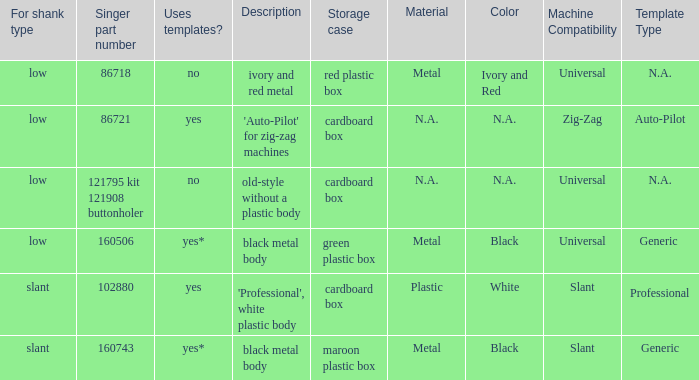What's the shank type of the buttonholer with red plastic box as storage case? Low. Parse the full table. {'header': ['For shank type', 'Singer part number', 'Uses templates?', 'Description', 'Storage case', 'Material', 'Color', 'Machine Compatibility', 'Template Type '], 'rows': [['low', '86718', 'no', 'ivory and red metal', 'red plastic box', 'Metal', 'Ivory and Red', 'Universal', 'N.A.'], ['low', '86721', 'yes', "'Auto-Pilot' for zig-zag machines", 'cardboard box', 'N.A.', 'N.A.', 'Zig-Zag', 'Auto-Pilot'], ['low', '121795 kit 121908 buttonholer', 'no', 'old-style without a plastic body', 'cardboard box', 'N.A.', 'N.A.', 'Universal', 'N.A.'], ['low', '160506', 'yes*', 'black metal body', 'green plastic box', 'Metal', 'Black', 'Universal', 'Generic '], ['slant', '102880', 'yes', "'Professional', white plastic body", 'cardboard box', 'Plastic', 'White', 'Slant', 'Professional '], ['slant', '160743', 'yes*', 'black metal body', 'maroon plastic box', 'Metal', 'Black', 'Slant', 'Generic']]} 